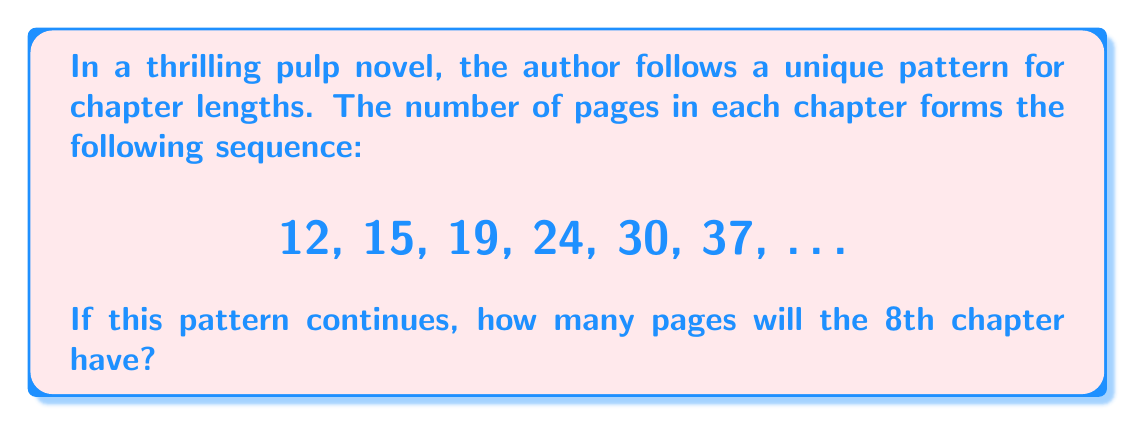Give your solution to this math problem. Let's analyze the sequence step-by-step:

1) First, we need to find the difference between consecutive terms:
   12 to 15: +3
   15 to 19: +4
   19 to 24: +5
   24 to 30: +6
   30 to 37: +7

2) We can see that the difference itself is increasing by 1 each time.

3) Let's express this mathematically. If we denote the nth term of the sequence as $a_n$, we can write:

   $a_{n+1} = a_n + (n+2)$

4) We're given the first 6 terms. Let's continue the pattern for the 7th and 8th terms:

   7th term: $a_7 = 37 + (6+2) = 37 + 8 = 45$
   8th term: $a_8 = 45 + (7+2) = 45 + 9 = 54$

5) Therefore, the 8th chapter will have 54 pages.

This pattern creates a sense of acceleration in the story, with each chapter getting progressively longer, mirroring the increasing tension and complexity often found in pulp novels.
Answer: 54 pages 